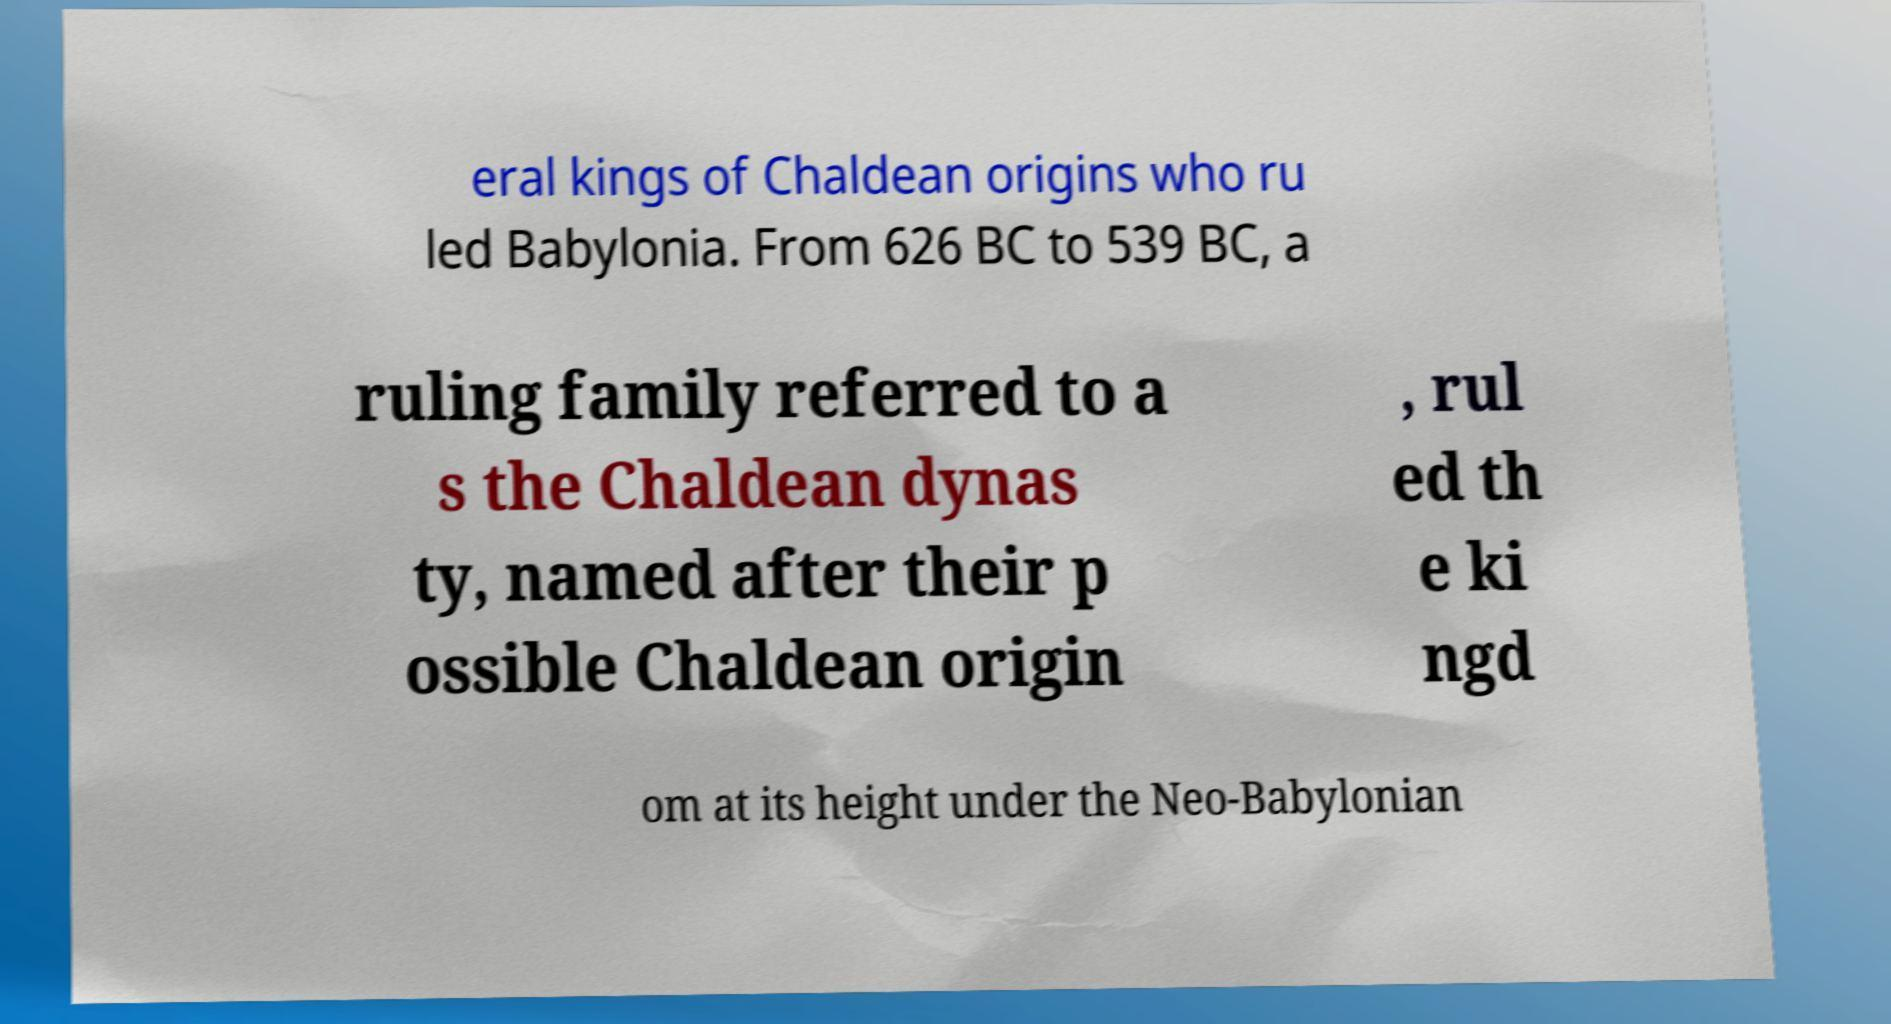Can you accurately transcribe the text from the provided image for me? eral kings of Chaldean origins who ru led Babylonia. From 626 BC to 539 BC, a ruling family referred to a s the Chaldean dynas ty, named after their p ossible Chaldean origin , rul ed th e ki ngd om at its height under the Neo-Babylonian 